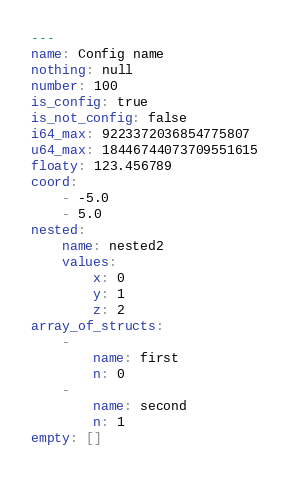Convert code to text. <code><loc_0><loc_0><loc_500><loc_500><_YAML_>---
name: Config name
nothing: null
number: 100
is_config: true
is_not_config: false
i64_max: 9223372036854775807
u64_max: 18446744073709551615
floaty: 123.456789
coord:
    - -5.0
    - 5.0
nested:
    name: nested2
    values:
        x: 0
        y: 1
        z: 2
array_of_structs:
    -
        name: first
        n: 0
    -
        name: second
        n: 1
empty: []
</code> 